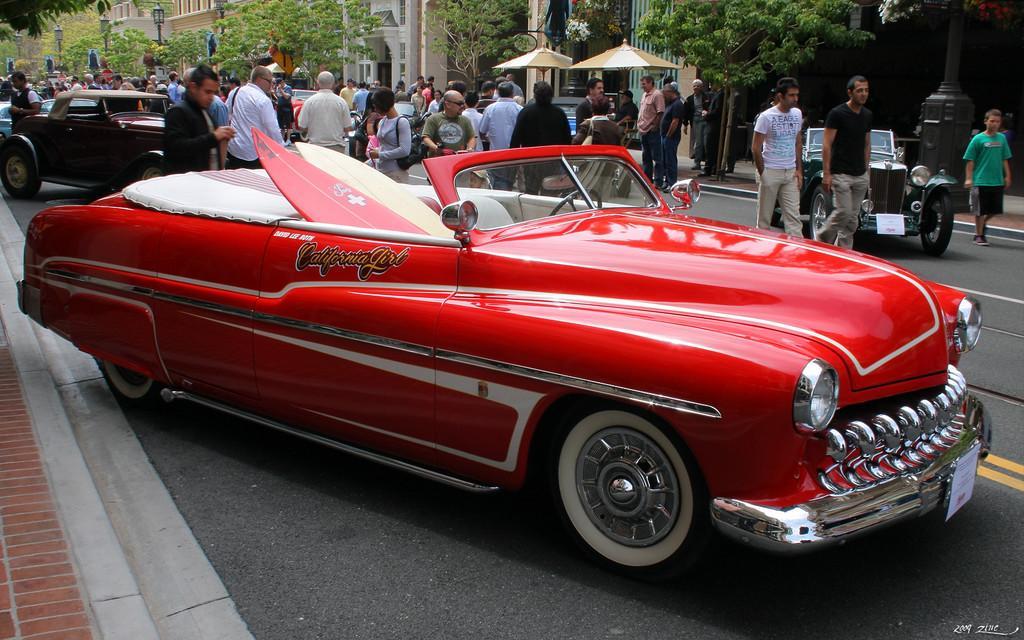Can you describe this image briefly? In this image there are cars on the road. Beside them people were standing. At the background there are trees, buildings and street lights. 